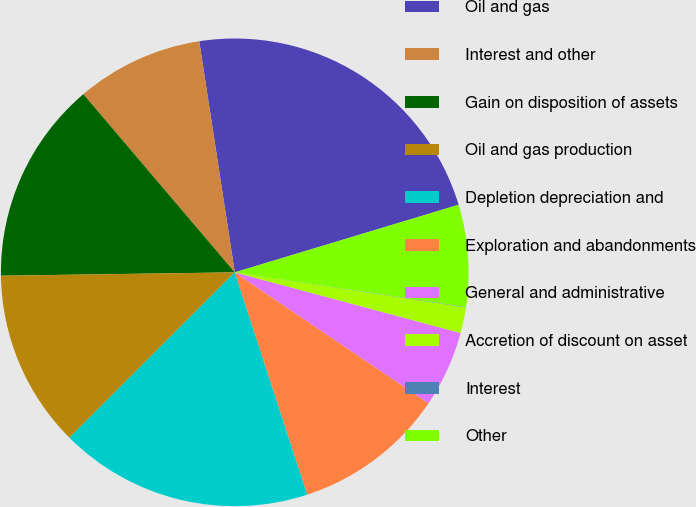Convert chart to OTSL. <chart><loc_0><loc_0><loc_500><loc_500><pie_chart><fcel>Oil and gas<fcel>Interest and other<fcel>Gain on disposition of assets<fcel>Oil and gas production<fcel>Depletion depreciation and<fcel>Exploration and abandonments<fcel>General and administrative<fcel>Accretion of discount on asset<fcel>Interest<fcel>Other<nl><fcel>22.76%<fcel>8.78%<fcel>14.02%<fcel>12.27%<fcel>17.52%<fcel>10.52%<fcel>5.28%<fcel>1.78%<fcel>0.03%<fcel>7.03%<nl></chart> 